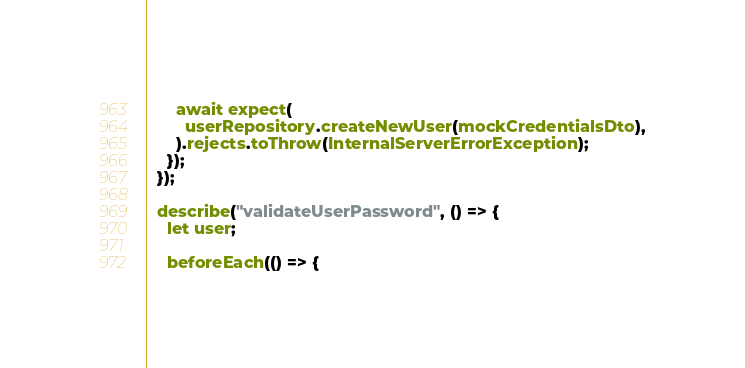Convert code to text. <code><loc_0><loc_0><loc_500><loc_500><_TypeScript_>      await expect(
        userRepository.createNewUser(mockCredentialsDto),
      ).rejects.toThrow(InternalServerErrorException);
    });
  });

  describe("validateUserPassword", () => {
    let user;

    beforeEach(() => {</code> 